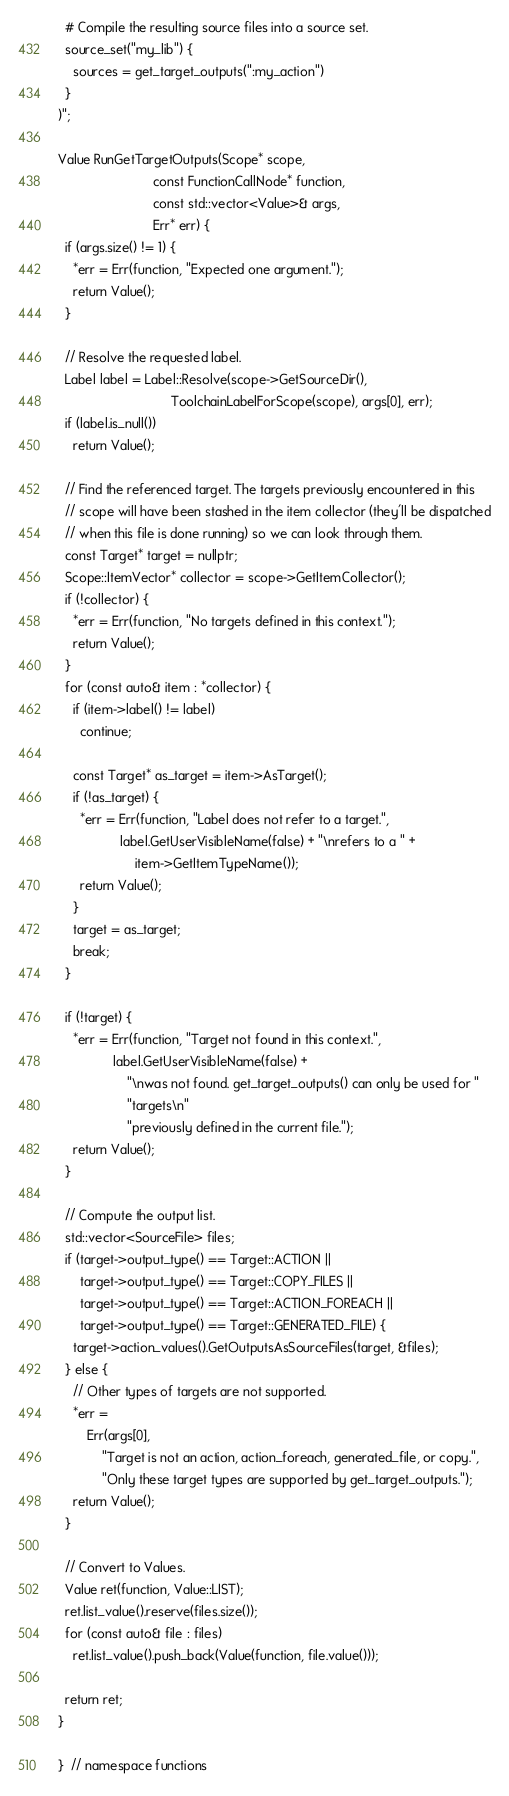<code> <loc_0><loc_0><loc_500><loc_500><_C++_>
  # Compile the resulting source files into a source set.
  source_set("my_lib") {
    sources = get_target_outputs(":my_action")
  }
)";

Value RunGetTargetOutputs(Scope* scope,
                          const FunctionCallNode* function,
                          const std::vector<Value>& args,
                          Err* err) {
  if (args.size() != 1) {
    *err = Err(function, "Expected one argument.");
    return Value();
  }

  // Resolve the requested label.
  Label label = Label::Resolve(scope->GetSourceDir(),
                               ToolchainLabelForScope(scope), args[0], err);
  if (label.is_null())
    return Value();

  // Find the referenced target. The targets previously encountered in this
  // scope will have been stashed in the item collector (they'll be dispatched
  // when this file is done running) so we can look through them.
  const Target* target = nullptr;
  Scope::ItemVector* collector = scope->GetItemCollector();
  if (!collector) {
    *err = Err(function, "No targets defined in this context.");
    return Value();
  }
  for (const auto& item : *collector) {
    if (item->label() != label)
      continue;

    const Target* as_target = item->AsTarget();
    if (!as_target) {
      *err = Err(function, "Label does not refer to a target.",
                 label.GetUserVisibleName(false) + "\nrefers to a " +
                     item->GetItemTypeName());
      return Value();
    }
    target = as_target;
    break;
  }

  if (!target) {
    *err = Err(function, "Target not found in this context.",
               label.GetUserVisibleName(false) +
                   "\nwas not found. get_target_outputs() can only be used for "
                   "targets\n"
                   "previously defined in the current file.");
    return Value();
  }

  // Compute the output list.
  std::vector<SourceFile> files;
  if (target->output_type() == Target::ACTION ||
      target->output_type() == Target::COPY_FILES ||
      target->output_type() == Target::ACTION_FOREACH ||
      target->output_type() == Target::GENERATED_FILE) {
    target->action_values().GetOutputsAsSourceFiles(target, &files);
  } else {
    // Other types of targets are not supported.
    *err =
        Err(args[0],
            "Target is not an action, action_foreach, generated_file, or copy.",
            "Only these target types are supported by get_target_outputs.");
    return Value();
  }

  // Convert to Values.
  Value ret(function, Value::LIST);
  ret.list_value().reserve(files.size());
  for (const auto& file : files)
    ret.list_value().push_back(Value(function, file.value()));

  return ret;
}

}  // namespace functions
</code> 